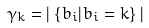Convert formula to latex. <formula><loc_0><loc_0><loc_500><loc_500>\gamma _ { k } & = | \left \{ b _ { i } | b _ { i } = k \right \} |</formula> 